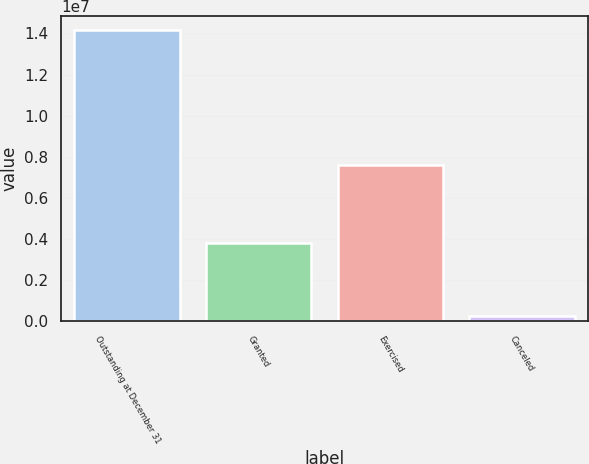Convert chart to OTSL. <chart><loc_0><loc_0><loc_500><loc_500><bar_chart><fcel>Outstanding at December 31<fcel>Granted<fcel>Exercised<fcel>Canceled<nl><fcel>1.4151e+07<fcel>3.78944e+06<fcel>7.57366e+06<fcel>226372<nl></chart> 